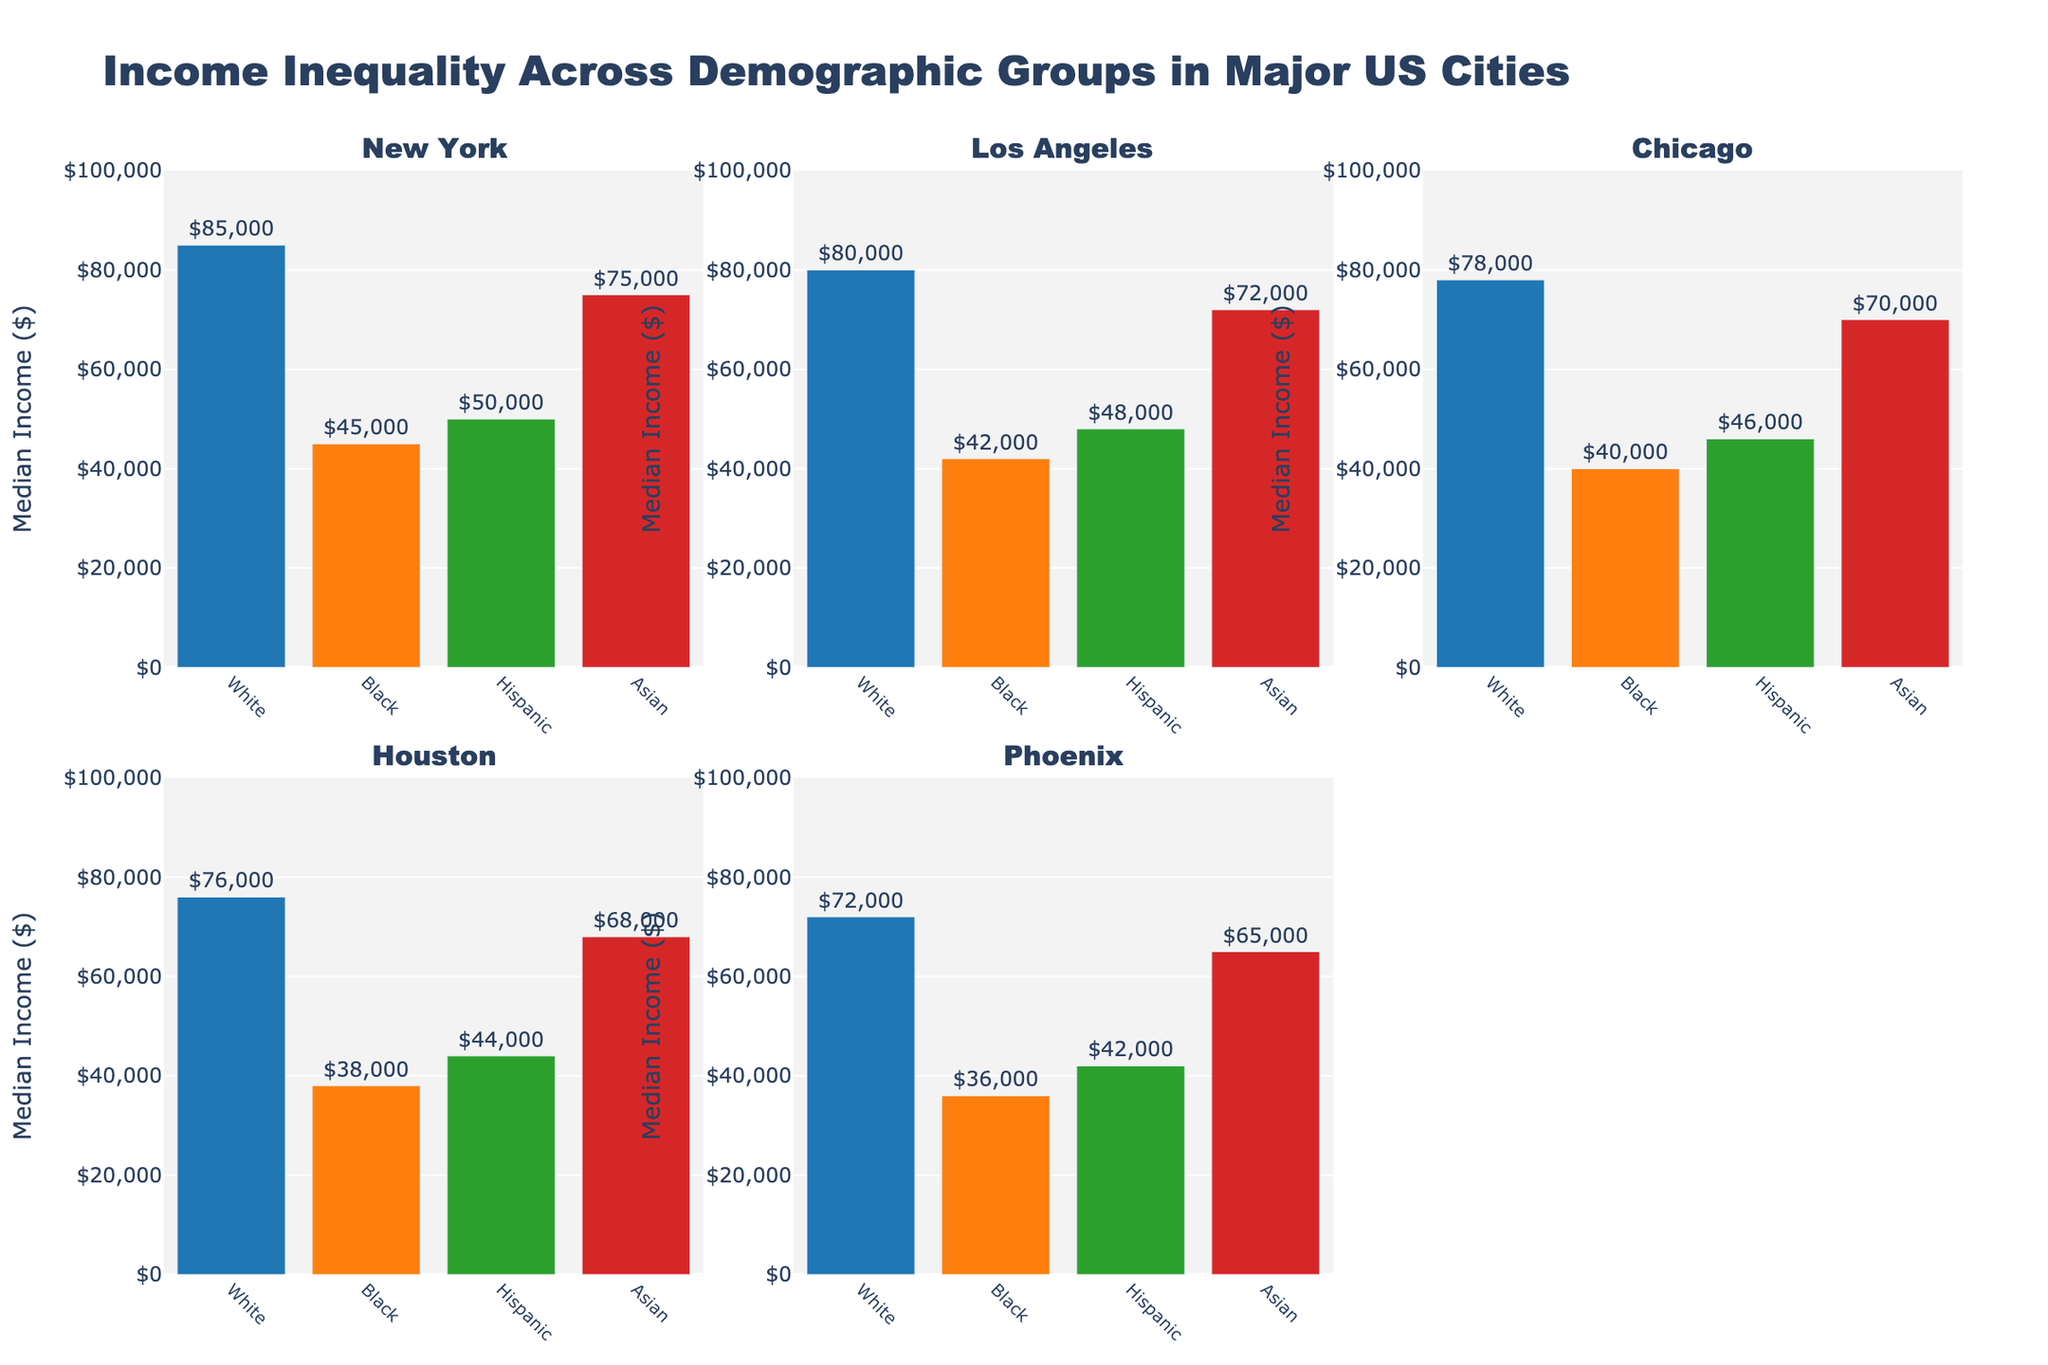what are the median incomes for each demographic group in New York City? Check the New York City plot and note the values labeled on each bar.
Answer: White: $85,000, Black: $45,000, Hispanic: $50,000, Asian: $75,000 Which city has the highest median income for the White group? Compare the median incomes for the White group across all city plots.
Answer: New York ($85,000) By how much does the median income of the Asian group in Los Angeles differ from that of the Hispanic group in the same city? Subtract the median income of the Hispanic group from that of the Asian group in Los Angeles.
Answer: $72,000 - $48,000 = $24,000 What is the range of median incomes for all demographic groups in Phoenix? Identify the highest and lowest median incomes for all groups in the Phoenix plot and subtract the lowest from the highest.
Answer: $72,000 - $36,000 = $36,000 Which demographic group in Chicago has the lowest median income, and what is it? Find the bar with the lowest labeled value in the Chicago plot.
Answer: Black: $40,000 How does the median income of the Black group in Houston compare to that of the same group in New York? Look at the income values of the Black group in Houston and New York, and compare them.
Answer: Lower in Houston ($38,000 vs. $45,000) In terms of median income, what is the combined total of the Hispanic group across all five cities? Sum the median income values of the Hispanic group from each city plot.
Answer: $50,000 + $48,000 + $46,000 + $44,000 + $42,000 = $230,000 Which city has the smallest income disparity between its highest and lowest median income groups, and what is the disparity? Calculate the differences between the highest and lowest incomes for each city and compare all results.
Answer: New York: $85,000 - $45,000 = $40,000, Los Angeles: $72,000 - $42,000 = $30,000, Chicago: $78,000 - $40,000 = $38,000, Houston: $76,000 - $38,000 = $38,000, Phoenix: $72,000 - $36,000 = $36,000; smallest is Los Angeles ($30,000) What is the median income of the Asian group in Dallas? Verify the data included to note that Dallas is not among the cities shown in the figure.
Answer: Not applicable 